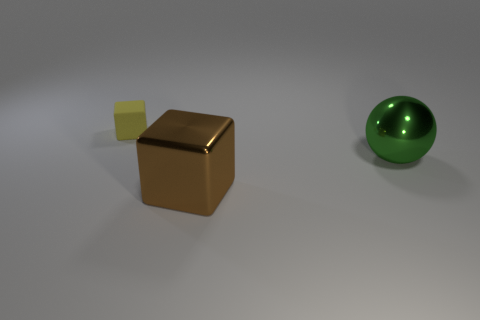Add 2 large yellow cylinders. How many objects exist? 5 Subtract all cubes. How many objects are left? 1 Add 1 brown shiny cubes. How many brown shiny cubes exist? 2 Subtract 0 yellow cylinders. How many objects are left? 3 Subtract all tiny matte cubes. Subtract all matte cubes. How many objects are left? 1 Add 1 large cubes. How many large cubes are left? 2 